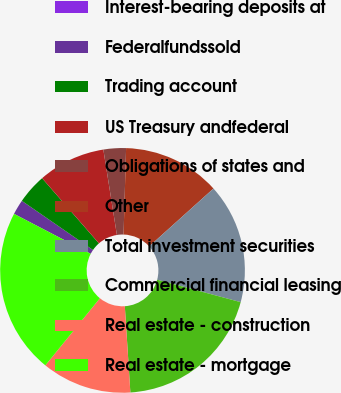<chart> <loc_0><loc_0><loc_500><loc_500><pie_chart><fcel>Interest-bearing deposits at<fcel>Federalfundssold<fcel>Trading account<fcel>US Treasury andfederal<fcel>Obligations of states and<fcel>Other<fcel>Total investment securities<fcel>Commercial financial leasing<fcel>Real estate - construction<fcel>Real estate - mortgage<nl><fcel>0.0%<fcel>1.98%<fcel>3.96%<fcel>8.91%<fcel>2.97%<fcel>12.87%<fcel>15.84%<fcel>19.8%<fcel>11.88%<fcel>21.78%<nl></chart> 